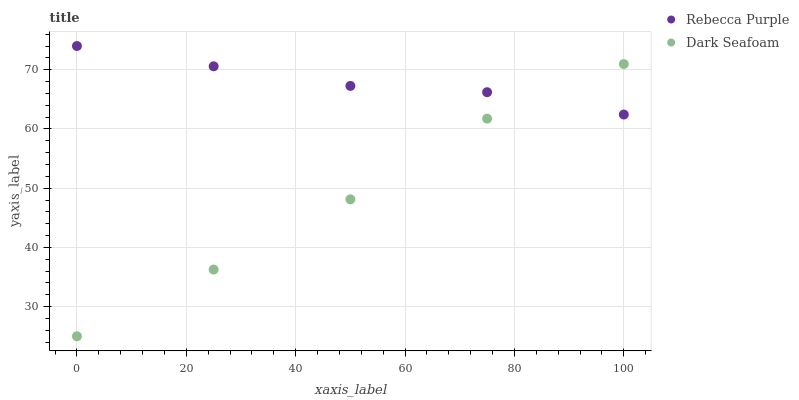Does Dark Seafoam have the minimum area under the curve?
Answer yes or no. Yes. Does Rebecca Purple have the maximum area under the curve?
Answer yes or no. Yes. Does Rebecca Purple have the minimum area under the curve?
Answer yes or no. No. Is Rebecca Purple the smoothest?
Answer yes or no. Yes. Is Dark Seafoam the roughest?
Answer yes or no. Yes. Is Rebecca Purple the roughest?
Answer yes or no. No. Does Dark Seafoam have the lowest value?
Answer yes or no. Yes. Does Rebecca Purple have the lowest value?
Answer yes or no. No. Does Rebecca Purple have the highest value?
Answer yes or no. Yes. Does Rebecca Purple intersect Dark Seafoam?
Answer yes or no. Yes. Is Rebecca Purple less than Dark Seafoam?
Answer yes or no. No. Is Rebecca Purple greater than Dark Seafoam?
Answer yes or no. No. 